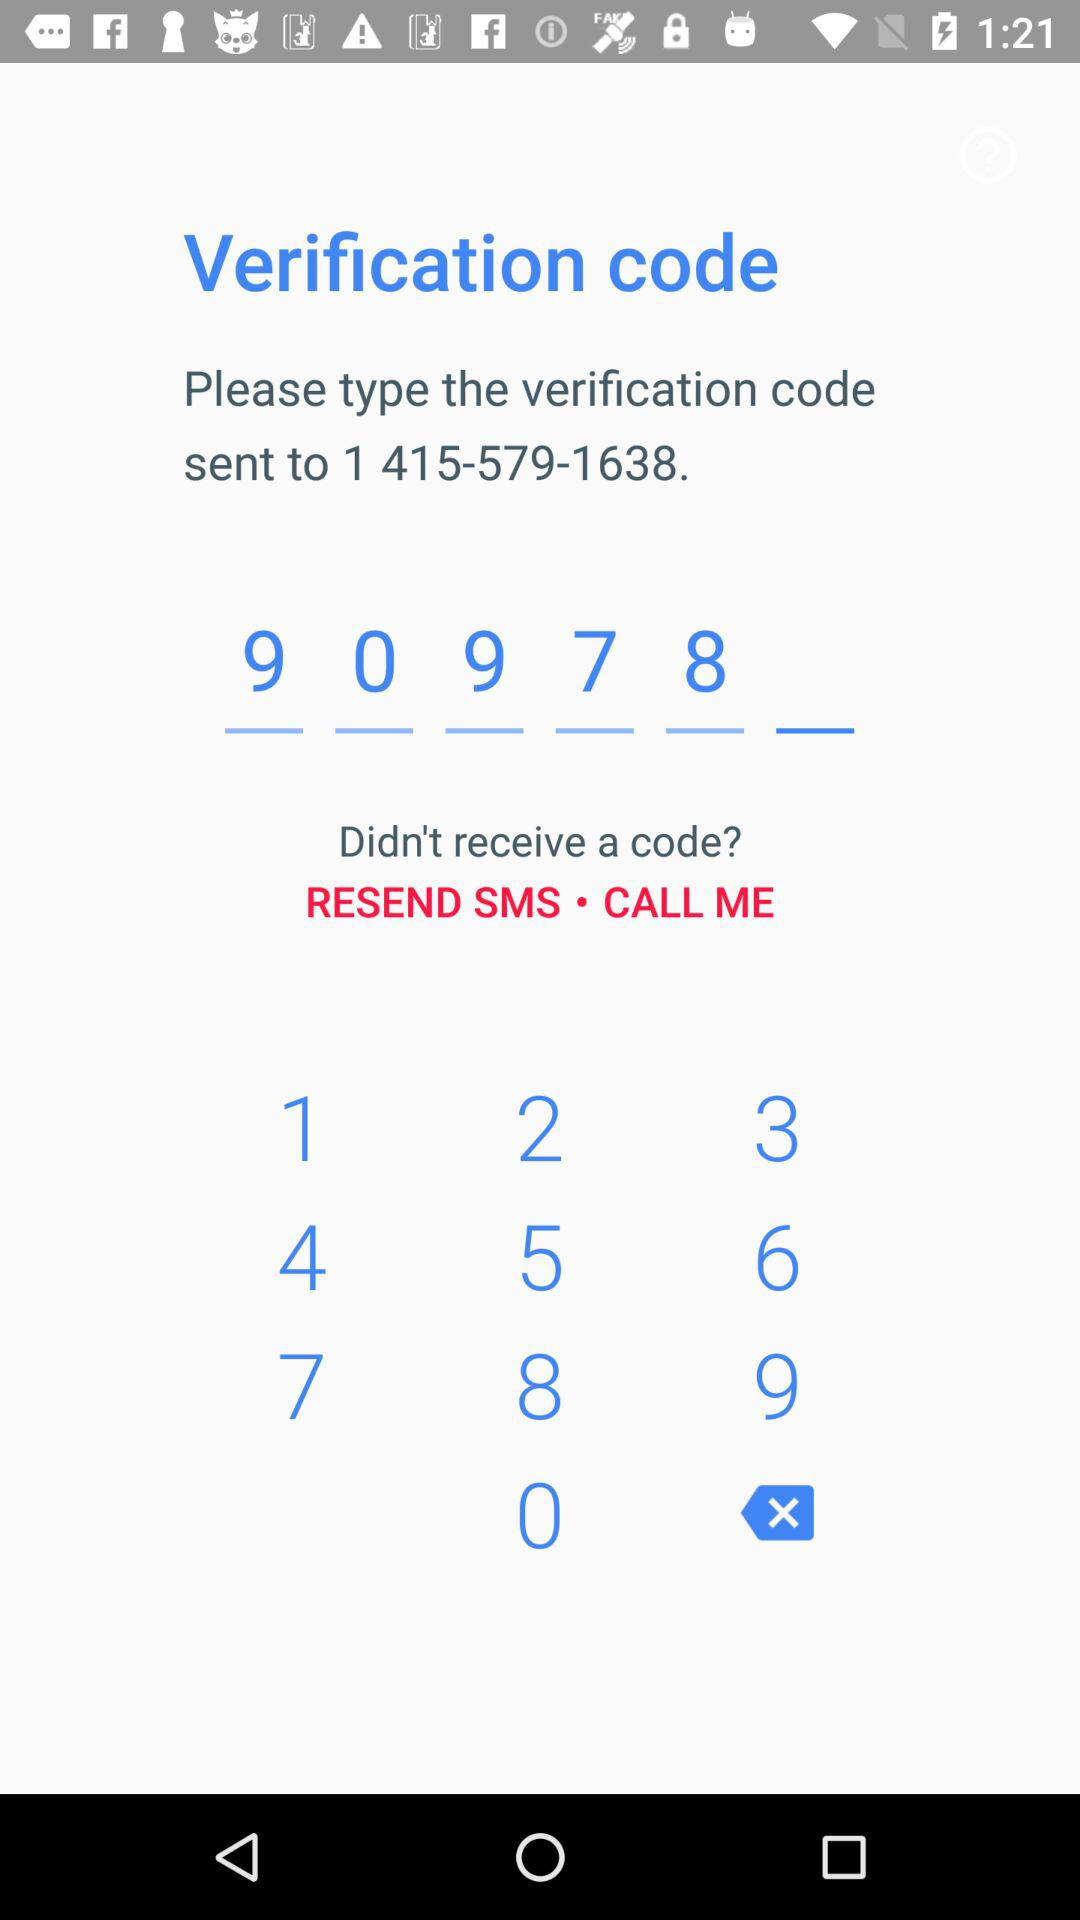To what number was the verification code sent? The verification code was sent to 1 415-579-1638. 